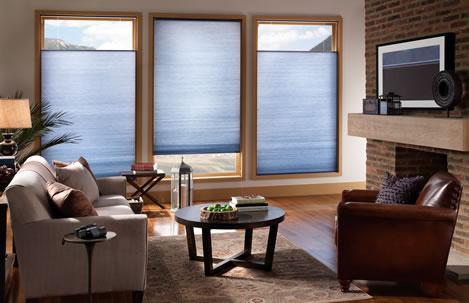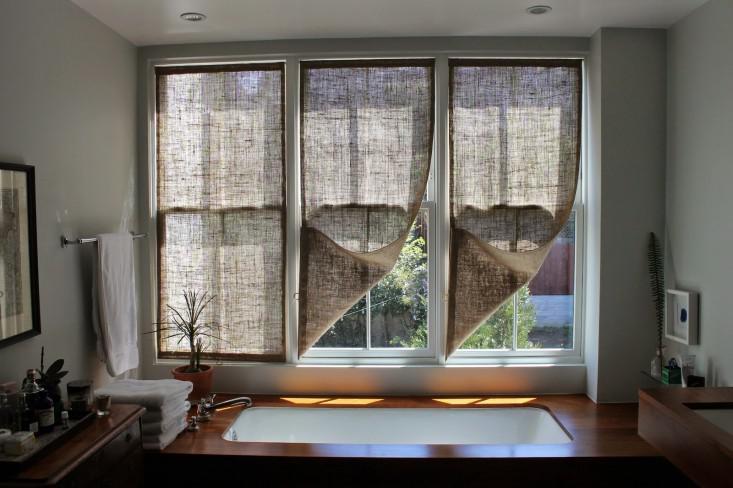The first image is the image on the left, the second image is the image on the right. Assess this claim about the two images: "Some shades are partially up.". Correct or not? Answer yes or no. Yes. The first image is the image on the left, the second image is the image on the right. Given the left and right images, does the statement "There are six blinds or window coverings." hold true? Answer yes or no. Yes. 